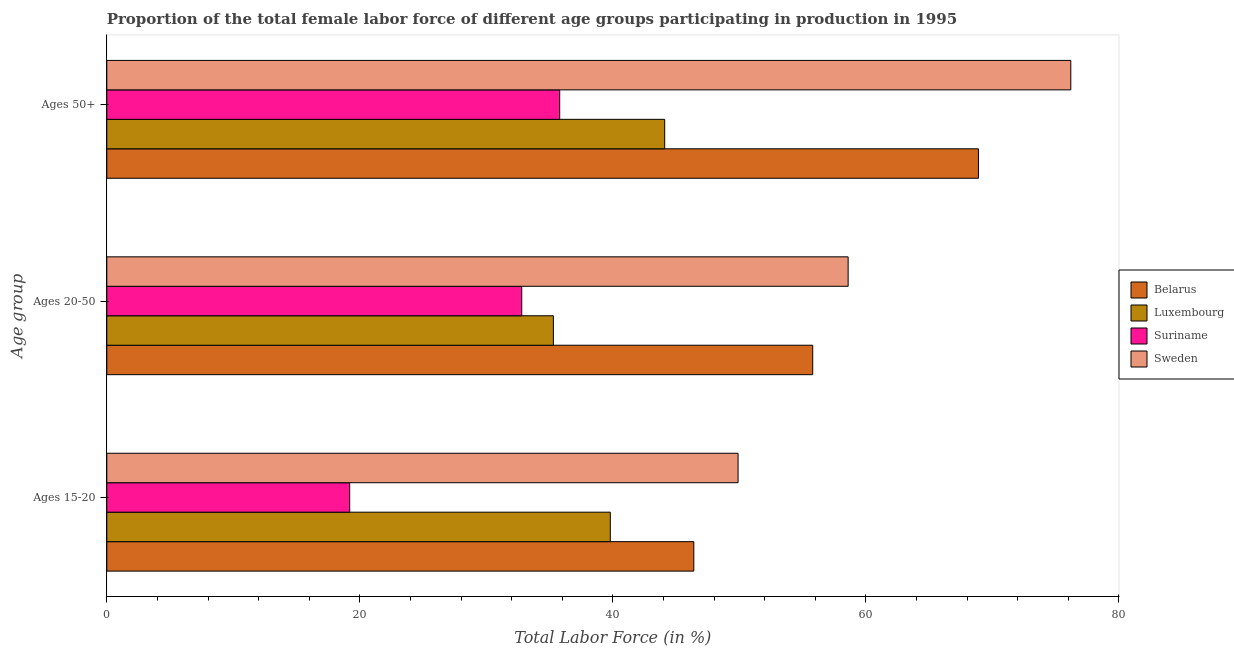How many different coloured bars are there?
Your answer should be very brief. 4. How many groups of bars are there?
Provide a short and direct response. 3. Are the number of bars per tick equal to the number of legend labels?
Make the answer very short. Yes. What is the label of the 2nd group of bars from the top?
Keep it short and to the point. Ages 20-50. What is the percentage of female labor force above age 50 in Suriname?
Provide a short and direct response. 35.8. Across all countries, what is the maximum percentage of female labor force above age 50?
Make the answer very short. 76.2. Across all countries, what is the minimum percentage of female labor force above age 50?
Provide a succinct answer. 35.8. In which country was the percentage of female labor force within the age group 20-50 maximum?
Offer a very short reply. Sweden. In which country was the percentage of female labor force within the age group 20-50 minimum?
Ensure brevity in your answer.  Suriname. What is the total percentage of female labor force above age 50 in the graph?
Give a very brief answer. 225. What is the difference between the percentage of female labor force above age 50 in Suriname and that in Belarus?
Provide a succinct answer. -33.1. What is the difference between the percentage of female labor force within the age group 15-20 in Suriname and the percentage of female labor force within the age group 20-50 in Belarus?
Your response must be concise. -36.6. What is the average percentage of female labor force within the age group 20-50 per country?
Keep it short and to the point. 45.62. What is the difference between the percentage of female labor force above age 50 and percentage of female labor force within the age group 20-50 in Luxembourg?
Keep it short and to the point. 8.8. What is the ratio of the percentage of female labor force within the age group 15-20 in Suriname to that in Luxembourg?
Your answer should be compact. 0.48. Is the percentage of female labor force within the age group 20-50 in Sweden less than that in Suriname?
Your answer should be compact. No. Is the difference between the percentage of female labor force within the age group 15-20 in Belarus and Sweden greater than the difference between the percentage of female labor force above age 50 in Belarus and Sweden?
Your answer should be very brief. Yes. What is the difference between the highest and the second highest percentage of female labor force within the age group 20-50?
Your answer should be compact. 2.8. What is the difference between the highest and the lowest percentage of female labor force above age 50?
Make the answer very short. 40.4. In how many countries, is the percentage of female labor force above age 50 greater than the average percentage of female labor force above age 50 taken over all countries?
Offer a very short reply. 2. What does the 1st bar from the top in Ages 50+ represents?
Your answer should be compact. Sweden. What does the 2nd bar from the bottom in Ages 50+ represents?
Offer a terse response. Luxembourg. Are the values on the major ticks of X-axis written in scientific E-notation?
Keep it short and to the point. No. Does the graph contain grids?
Your answer should be compact. No. Where does the legend appear in the graph?
Your answer should be compact. Center right. How are the legend labels stacked?
Your answer should be compact. Vertical. What is the title of the graph?
Your response must be concise. Proportion of the total female labor force of different age groups participating in production in 1995. What is the label or title of the X-axis?
Make the answer very short. Total Labor Force (in %). What is the label or title of the Y-axis?
Your answer should be compact. Age group. What is the Total Labor Force (in %) in Belarus in Ages 15-20?
Give a very brief answer. 46.4. What is the Total Labor Force (in %) in Luxembourg in Ages 15-20?
Ensure brevity in your answer.  39.8. What is the Total Labor Force (in %) of Suriname in Ages 15-20?
Give a very brief answer. 19.2. What is the Total Labor Force (in %) in Sweden in Ages 15-20?
Make the answer very short. 49.9. What is the Total Labor Force (in %) of Belarus in Ages 20-50?
Provide a succinct answer. 55.8. What is the Total Labor Force (in %) of Luxembourg in Ages 20-50?
Provide a succinct answer. 35.3. What is the Total Labor Force (in %) in Suriname in Ages 20-50?
Ensure brevity in your answer.  32.8. What is the Total Labor Force (in %) of Sweden in Ages 20-50?
Ensure brevity in your answer.  58.6. What is the Total Labor Force (in %) in Belarus in Ages 50+?
Your answer should be compact. 68.9. What is the Total Labor Force (in %) of Luxembourg in Ages 50+?
Your response must be concise. 44.1. What is the Total Labor Force (in %) in Suriname in Ages 50+?
Ensure brevity in your answer.  35.8. What is the Total Labor Force (in %) in Sweden in Ages 50+?
Provide a short and direct response. 76.2. Across all Age group, what is the maximum Total Labor Force (in %) in Belarus?
Give a very brief answer. 68.9. Across all Age group, what is the maximum Total Labor Force (in %) of Luxembourg?
Your answer should be very brief. 44.1. Across all Age group, what is the maximum Total Labor Force (in %) in Suriname?
Ensure brevity in your answer.  35.8. Across all Age group, what is the maximum Total Labor Force (in %) of Sweden?
Offer a very short reply. 76.2. Across all Age group, what is the minimum Total Labor Force (in %) of Belarus?
Offer a terse response. 46.4. Across all Age group, what is the minimum Total Labor Force (in %) in Luxembourg?
Offer a very short reply. 35.3. Across all Age group, what is the minimum Total Labor Force (in %) in Suriname?
Your response must be concise. 19.2. Across all Age group, what is the minimum Total Labor Force (in %) of Sweden?
Provide a short and direct response. 49.9. What is the total Total Labor Force (in %) of Belarus in the graph?
Provide a short and direct response. 171.1. What is the total Total Labor Force (in %) of Luxembourg in the graph?
Your answer should be compact. 119.2. What is the total Total Labor Force (in %) of Suriname in the graph?
Make the answer very short. 87.8. What is the total Total Labor Force (in %) of Sweden in the graph?
Your answer should be compact. 184.7. What is the difference between the Total Labor Force (in %) in Belarus in Ages 15-20 and that in Ages 20-50?
Your answer should be very brief. -9.4. What is the difference between the Total Labor Force (in %) in Suriname in Ages 15-20 and that in Ages 20-50?
Your response must be concise. -13.6. What is the difference between the Total Labor Force (in %) in Sweden in Ages 15-20 and that in Ages 20-50?
Provide a short and direct response. -8.7. What is the difference between the Total Labor Force (in %) of Belarus in Ages 15-20 and that in Ages 50+?
Offer a terse response. -22.5. What is the difference between the Total Labor Force (in %) in Suriname in Ages 15-20 and that in Ages 50+?
Offer a terse response. -16.6. What is the difference between the Total Labor Force (in %) of Sweden in Ages 15-20 and that in Ages 50+?
Offer a very short reply. -26.3. What is the difference between the Total Labor Force (in %) of Belarus in Ages 20-50 and that in Ages 50+?
Offer a very short reply. -13.1. What is the difference between the Total Labor Force (in %) of Luxembourg in Ages 20-50 and that in Ages 50+?
Make the answer very short. -8.8. What is the difference between the Total Labor Force (in %) of Suriname in Ages 20-50 and that in Ages 50+?
Keep it short and to the point. -3. What is the difference between the Total Labor Force (in %) in Sweden in Ages 20-50 and that in Ages 50+?
Your answer should be compact. -17.6. What is the difference between the Total Labor Force (in %) of Belarus in Ages 15-20 and the Total Labor Force (in %) of Luxembourg in Ages 20-50?
Your answer should be compact. 11.1. What is the difference between the Total Labor Force (in %) in Belarus in Ages 15-20 and the Total Labor Force (in %) in Suriname in Ages 20-50?
Your answer should be compact. 13.6. What is the difference between the Total Labor Force (in %) in Belarus in Ages 15-20 and the Total Labor Force (in %) in Sweden in Ages 20-50?
Keep it short and to the point. -12.2. What is the difference between the Total Labor Force (in %) of Luxembourg in Ages 15-20 and the Total Labor Force (in %) of Suriname in Ages 20-50?
Give a very brief answer. 7. What is the difference between the Total Labor Force (in %) of Luxembourg in Ages 15-20 and the Total Labor Force (in %) of Sweden in Ages 20-50?
Make the answer very short. -18.8. What is the difference between the Total Labor Force (in %) of Suriname in Ages 15-20 and the Total Labor Force (in %) of Sweden in Ages 20-50?
Make the answer very short. -39.4. What is the difference between the Total Labor Force (in %) in Belarus in Ages 15-20 and the Total Labor Force (in %) in Luxembourg in Ages 50+?
Your answer should be very brief. 2.3. What is the difference between the Total Labor Force (in %) of Belarus in Ages 15-20 and the Total Labor Force (in %) of Sweden in Ages 50+?
Make the answer very short. -29.8. What is the difference between the Total Labor Force (in %) in Luxembourg in Ages 15-20 and the Total Labor Force (in %) in Sweden in Ages 50+?
Your answer should be very brief. -36.4. What is the difference between the Total Labor Force (in %) in Suriname in Ages 15-20 and the Total Labor Force (in %) in Sweden in Ages 50+?
Make the answer very short. -57. What is the difference between the Total Labor Force (in %) in Belarus in Ages 20-50 and the Total Labor Force (in %) in Luxembourg in Ages 50+?
Your response must be concise. 11.7. What is the difference between the Total Labor Force (in %) in Belarus in Ages 20-50 and the Total Labor Force (in %) in Suriname in Ages 50+?
Your answer should be very brief. 20. What is the difference between the Total Labor Force (in %) of Belarus in Ages 20-50 and the Total Labor Force (in %) of Sweden in Ages 50+?
Offer a terse response. -20.4. What is the difference between the Total Labor Force (in %) in Luxembourg in Ages 20-50 and the Total Labor Force (in %) in Sweden in Ages 50+?
Your answer should be compact. -40.9. What is the difference between the Total Labor Force (in %) of Suriname in Ages 20-50 and the Total Labor Force (in %) of Sweden in Ages 50+?
Offer a very short reply. -43.4. What is the average Total Labor Force (in %) of Belarus per Age group?
Provide a short and direct response. 57.03. What is the average Total Labor Force (in %) of Luxembourg per Age group?
Your answer should be compact. 39.73. What is the average Total Labor Force (in %) of Suriname per Age group?
Ensure brevity in your answer.  29.27. What is the average Total Labor Force (in %) in Sweden per Age group?
Keep it short and to the point. 61.57. What is the difference between the Total Labor Force (in %) of Belarus and Total Labor Force (in %) of Suriname in Ages 15-20?
Make the answer very short. 27.2. What is the difference between the Total Labor Force (in %) in Luxembourg and Total Labor Force (in %) in Suriname in Ages 15-20?
Offer a terse response. 20.6. What is the difference between the Total Labor Force (in %) of Suriname and Total Labor Force (in %) of Sweden in Ages 15-20?
Your answer should be compact. -30.7. What is the difference between the Total Labor Force (in %) of Belarus and Total Labor Force (in %) of Luxembourg in Ages 20-50?
Make the answer very short. 20.5. What is the difference between the Total Labor Force (in %) in Belarus and Total Labor Force (in %) in Suriname in Ages 20-50?
Make the answer very short. 23. What is the difference between the Total Labor Force (in %) in Belarus and Total Labor Force (in %) in Sweden in Ages 20-50?
Provide a succinct answer. -2.8. What is the difference between the Total Labor Force (in %) of Luxembourg and Total Labor Force (in %) of Suriname in Ages 20-50?
Your response must be concise. 2.5. What is the difference between the Total Labor Force (in %) of Luxembourg and Total Labor Force (in %) of Sweden in Ages 20-50?
Your answer should be compact. -23.3. What is the difference between the Total Labor Force (in %) in Suriname and Total Labor Force (in %) in Sweden in Ages 20-50?
Offer a very short reply. -25.8. What is the difference between the Total Labor Force (in %) in Belarus and Total Labor Force (in %) in Luxembourg in Ages 50+?
Provide a short and direct response. 24.8. What is the difference between the Total Labor Force (in %) in Belarus and Total Labor Force (in %) in Suriname in Ages 50+?
Give a very brief answer. 33.1. What is the difference between the Total Labor Force (in %) in Belarus and Total Labor Force (in %) in Sweden in Ages 50+?
Your answer should be compact. -7.3. What is the difference between the Total Labor Force (in %) of Luxembourg and Total Labor Force (in %) of Suriname in Ages 50+?
Your answer should be compact. 8.3. What is the difference between the Total Labor Force (in %) in Luxembourg and Total Labor Force (in %) in Sweden in Ages 50+?
Offer a terse response. -32.1. What is the difference between the Total Labor Force (in %) of Suriname and Total Labor Force (in %) of Sweden in Ages 50+?
Your answer should be very brief. -40.4. What is the ratio of the Total Labor Force (in %) in Belarus in Ages 15-20 to that in Ages 20-50?
Offer a terse response. 0.83. What is the ratio of the Total Labor Force (in %) in Luxembourg in Ages 15-20 to that in Ages 20-50?
Your answer should be very brief. 1.13. What is the ratio of the Total Labor Force (in %) in Suriname in Ages 15-20 to that in Ages 20-50?
Your answer should be compact. 0.59. What is the ratio of the Total Labor Force (in %) in Sweden in Ages 15-20 to that in Ages 20-50?
Your answer should be compact. 0.85. What is the ratio of the Total Labor Force (in %) in Belarus in Ages 15-20 to that in Ages 50+?
Your answer should be very brief. 0.67. What is the ratio of the Total Labor Force (in %) of Luxembourg in Ages 15-20 to that in Ages 50+?
Offer a very short reply. 0.9. What is the ratio of the Total Labor Force (in %) in Suriname in Ages 15-20 to that in Ages 50+?
Offer a very short reply. 0.54. What is the ratio of the Total Labor Force (in %) in Sweden in Ages 15-20 to that in Ages 50+?
Offer a terse response. 0.65. What is the ratio of the Total Labor Force (in %) in Belarus in Ages 20-50 to that in Ages 50+?
Provide a short and direct response. 0.81. What is the ratio of the Total Labor Force (in %) of Luxembourg in Ages 20-50 to that in Ages 50+?
Your response must be concise. 0.8. What is the ratio of the Total Labor Force (in %) in Suriname in Ages 20-50 to that in Ages 50+?
Provide a succinct answer. 0.92. What is the ratio of the Total Labor Force (in %) in Sweden in Ages 20-50 to that in Ages 50+?
Provide a short and direct response. 0.77. What is the difference between the highest and the second highest Total Labor Force (in %) in Belarus?
Keep it short and to the point. 13.1. What is the difference between the highest and the second highest Total Labor Force (in %) in Luxembourg?
Your response must be concise. 4.3. What is the difference between the highest and the second highest Total Labor Force (in %) of Sweden?
Make the answer very short. 17.6. What is the difference between the highest and the lowest Total Labor Force (in %) in Suriname?
Offer a very short reply. 16.6. What is the difference between the highest and the lowest Total Labor Force (in %) in Sweden?
Make the answer very short. 26.3. 